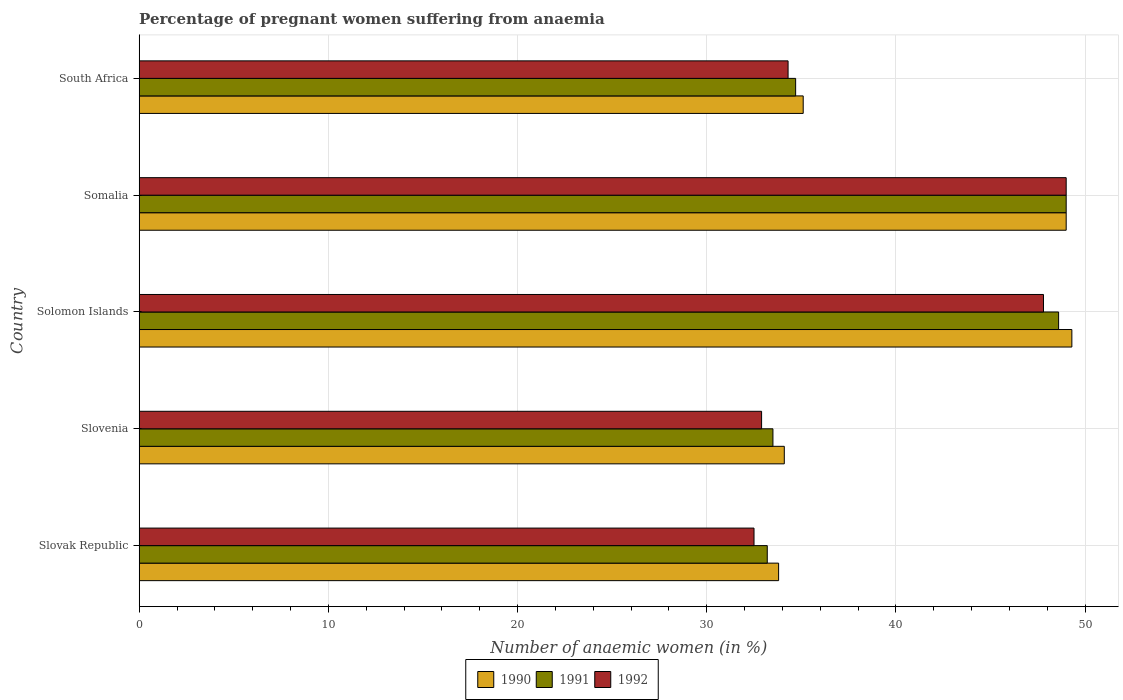How many different coloured bars are there?
Keep it short and to the point. 3. How many bars are there on the 3rd tick from the bottom?
Keep it short and to the point. 3. What is the label of the 2nd group of bars from the top?
Provide a short and direct response. Somalia. In how many cases, is the number of bars for a given country not equal to the number of legend labels?
Give a very brief answer. 0. What is the number of anaemic women in 1991 in Somalia?
Offer a terse response. 49. Across all countries, what is the minimum number of anaemic women in 1990?
Provide a short and direct response. 33.8. In which country was the number of anaemic women in 1990 maximum?
Your response must be concise. Solomon Islands. In which country was the number of anaemic women in 1991 minimum?
Give a very brief answer. Slovak Republic. What is the total number of anaemic women in 1992 in the graph?
Your answer should be compact. 196.5. What is the difference between the number of anaemic women in 1991 in Solomon Islands and the number of anaemic women in 1990 in Somalia?
Your response must be concise. -0.4. What is the average number of anaemic women in 1991 per country?
Your answer should be compact. 39.8. What is the difference between the number of anaemic women in 1992 and number of anaemic women in 1991 in Solomon Islands?
Provide a short and direct response. -0.8. What is the ratio of the number of anaemic women in 1990 in Slovak Republic to that in South Africa?
Offer a very short reply. 0.96. Is the number of anaemic women in 1991 in Slovak Republic less than that in Slovenia?
Provide a short and direct response. Yes. Is the difference between the number of anaemic women in 1992 in Slovak Republic and Solomon Islands greater than the difference between the number of anaemic women in 1991 in Slovak Republic and Solomon Islands?
Provide a short and direct response. Yes. What is the difference between the highest and the second highest number of anaemic women in 1990?
Your answer should be very brief. 0.3. What does the 1st bar from the bottom in South Africa represents?
Offer a terse response. 1990. How many countries are there in the graph?
Offer a very short reply. 5. What is the difference between two consecutive major ticks on the X-axis?
Your response must be concise. 10. Are the values on the major ticks of X-axis written in scientific E-notation?
Give a very brief answer. No. Does the graph contain grids?
Make the answer very short. Yes. How many legend labels are there?
Keep it short and to the point. 3. How are the legend labels stacked?
Ensure brevity in your answer.  Horizontal. What is the title of the graph?
Ensure brevity in your answer.  Percentage of pregnant women suffering from anaemia. Does "1972" appear as one of the legend labels in the graph?
Offer a terse response. No. What is the label or title of the X-axis?
Offer a very short reply. Number of anaemic women (in %). What is the Number of anaemic women (in %) of 1990 in Slovak Republic?
Your answer should be very brief. 33.8. What is the Number of anaemic women (in %) of 1991 in Slovak Republic?
Provide a succinct answer. 33.2. What is the Number of anaemic women (in %) of 1992 in Slovak Republic?
Make the answer very short. 32.5. What is the Number of anaemic women (in %) of 1990 in Slovenia?
Provide a short and direct response. 34.1. What is the Number of anaemic women (in %) in 1991 in Slovenia?
Your answer should be compact. 33.5. What is the Number of anaemic women (in %) in 1992 in Slovenia?
Ensure brevity in your answer.  32.9. What is the Number of anaemic women (in %) in 1990 in Solomon Islands?
Your answer should be very brief. 49.3. What is the Number of anaemic women (in %) in 1991 in Solomon Islands?
Your answer should be very brief. 48.6. What is the Number of anaemic women (in %) of 1992 in Solomon Islands?
Your answer should be very brief. 47.8. What is the Number of anaemic women (in %) in 1991 in Somalia?
Offer a terse response. 49. What is the Number of anaemic women (in %) in 1992 in Somalia?
Ensure brevity in your answer.  49. What is the Number of anaemic women (in %) in 1990 in South Africa?
Provide a short and direct response. 35.1. What is the Number of anaemic women (in %) in 1991 in South Africa?
Make the answer very short. 34.7. What is the Number of anaemic women (in %) of 1992 in South Africa?
Give a very brief answer. 34.3. Across all countries, what is the maximum Number of anaemic women (in %) of 1990?
Keep it short and to the point. 49.3. Across all countries, what is the maximum Number of anaemic women (in %) in 1991?
Ensure brevity in your answer.  49. Across all countries, what is the maximum Number of anaemic women (in %) in 1992?
Your answer should be very brief. 49. Across all countries, what is the minimum Number of anaemic women (in %) in 1990?
Your answer should be very brief. 33.8. Across all countries, what is the minimum Number of anaemic women (in %) of 1991?
Make the answer very short. 33.2. Across all countries, what is the minimum Number of anaemic women (in %) of 1992?
Provide a succinct answer. 32.5. What is the total Number of anaemic women (in %) in 1990 in the graph?
Offer a terse response. 201.3. What is the total Number of anaemic women (in %) of 1991 in the graph?
Offer a very short reply. 199. What is the total Number of anaemic women (in %) of 1992 in the graph?
Make the answer very short. 196.5. What is the difference between the Number of anaemic women (in %) of 1991 in Slovak Republic and that in Slovenia?
Offer a terse response. -0.3. What is the difference between the Number of anaemic women (in %) in 1992 in Slovak Republic and that in Slovenia?
Your answer should be very brief. -0.4. What is the difference between the Number of anaemic women (in %) of 1990 in Slovak Republic and that in Solomon Islands?
Keep it short and to the point. -15.5. What is the difference between the Number of anaemic women (in %) of 1991 in Slovak Republic and that in Solomon Islands?
Make the answer very short. -15.4. What is the difference between the Number of anaemic women (in %) in 1992 in Slovak Republic and that in Solomon Islands?
Provide a succinct answer. -15.3. What is the difference between the Number of anaemic women (in %) in 1990 in Slovak Republic and that in Somalia?
Provide a succinct answer. -15.2. What is the difference between the Number of anaemic women (in %) of 1991 in Slovak Republic and that in Somalia?
Offer a terse response. -15.8. What is the difference between the Number of anaemic women (in %) of 1992 in Slovak Republic and that in Somalia?
Make the answer very short. -16.5. What is the difference between the Number of anaemic women (in %) of 1990 in Slovak Republic and that in South Africa?
Offer a terse response. -1.3. What is the difference between the Number of anaemic women (in %) of 1991 in Slovak Republic and that in South Africa?
Ensure brevity in your answer.  -1.5. What is the difference between the Number of anaemic women (in %) in 1992 in Slovak Republic and that in South Africa?
Offer a very short reply. -1.8. What is the difference between the Number of anaemic women (in %) in 1990 in Slovenia and that in Solomon Islands?
Keep it short and to the point. -15.2. What is the difference between the Number of anaemic women (in %) of 1991 in Slovenia and that in Solomon Islands?
Provide a succinct answer. -15.1. What is the difference between the Number of anaemic women (in %) of 1992 in Slovenia and that in Solomon Islands?
Offer a terse response. -14.9. What is the difference between the Number of anaemic women (in %) in 1990 in Slovenia and that in Somalia?
Ensure brevity in your answer.  -14.9. What is the difference between the Number of anaemic women (in %) in 1991 in Slovenia and that in Somalia?
Your answer should be very brief. -15.5. What is the difference between the Number of anaemic women (in %) in 1992 in Slovenia and that in Somalia?
Provide a succinct answer. -16.1. What is the difference between the Number of anaemic women (in %) in 1990 in Slovenia and that in South Africa?
Offer a terse response. -1. What is the difference between the Number of anaemic women (in %) in 1990 in Solomon Islands and that in Somalia?
Your response must be concise. 0.3. What is the difference between the Number of anaemic women (in %) in 1991 in Solomon Islands and that in Somalia?
Your response must be concise. -0.4. What is the difference between the Number of anaemic women (in %) in 1991 in Solomon Islands and that in South Africa?
Keep it short and to the point. 13.9. What is the difference between the Number of anaemic women (in %) in 1992 in Somalia and that in South Africa?
Offer a terse response. 14.7. What is the difference between the Number of anaemic women (in %) of 1990 in Slovak Republic and the Number of anaemic women (in %) of 1992 in Slovenia?
Provide a short and direct response. 0.9. What is the difference between the Number of anaemic women (in %) in 1991 in Slovak Republic and the Number of anaemic women (in %) in 1992 in Slovenia?
Provide a succinct answer. 0.3. What is the difference between the Number of anaemic women (in %) in 1990 in Slovak Republic and the Number of anaemic women (in %) in 1991 in Solomon Islands?
Ensure brevity in your answer.  -14.8. What is the difference between the Number of anaemic women (in %) in 1991 in Slovak Republic and the Number of anaemic women (in %) in 1992 in Solomon Islands?
Give a very brief answer. -14.6. What is the difference between the Number of anaemic women (in %) in 1990 in Slovak Republic and the Number of anaemic women (in %) in 1991 in Somalia?
Offer a terse response. -15.2. What is the difference between the Number of anaemic women (in %) in 1990 in Slovak Republic and the Number of anaemic women (in %) in 1992 in Somalia?
Provide a succinct answer. -15.2. What is the difference between the Number of anaemic women (in %) in 1991 in Slovak Republic and the Number of anaemic women (in %) in 1992 in Somalia?
Your answer should be very brief. -15.8. What is the difference between the Number of anaemic women (in %) in 1990 in Slovak Republic and the Number of anaemic women (in %) in 1991 in South Africa?
Give a very brief answer. -0.9. What is the difference between the Number of anaemic women (in %) in 1990 in Slovenia and the Number of anaemic women (in %) in 1992 in Solomon Islands?
Provide a succinct answer. -13.7. What is the difference between the Number of anaemic women (in %) of 1991 in Slovenia and the Number of anaemic women (in %) of 1992 in Solomon Islands?
Your answer should be very brief. -14.3. What is the difference between the Number of anaemic women (in %) in 1990 in Slovenia and the Number of anaemic women (in %) in 1991 in Somalia?
Provide a short and direct response. -14.9. What is the difference between the Number of anaemic women (in %) in 1990 in Slovenia and the Number of anaemic women (in %) in 1992 in Somalia?
Your answer should be very brief. -14.9. What is the difference between the Number of anaemic women (in %) of 1991 in Slovenia and the Number of anaemic women (in %) of 1992 in Somalia?
Provide a succinct answer. -15.5. What is the difference between the Number of anaemic women (in %) in 1990 in Slovenia and the Number of anaemic women (in %) in 1992 in South Africa?
Keep it short and to the point. -0.2. What is the difference between the Number of anaemic women (in %) of 1991 in Slovenia and the Number of anaemic women (in %) of 1992 in South Africa?
Your answer should be very brief. -0.8. What is the difference between the Number of anaemic women (in %) in 1990 in Solomon Islands and the Number of anaemic women (in %) in 1991 in Somalia?
Give a very brief answer. 0.3. What is the difference between the Number of anaemic women (in %) of 1991 in Solomon Islands and the Number of anaemic women (in %) of 1992 in Somalia?
Offer a very short reply. -0.4. What is the difference between the Number of anaemic women (in %) in 1990 in Solomon Islands and the Number of anaemic women (in %) in 1991 in South Africa?
Keep it short and to the point. 14.6. What is the difference between the Number of anaemic women (in %) of 1990 in Somalia and the Number of anaemic women (in %) of 1991 in South Africa?
Ensure brevity in your answer.  14.3. What is the difference between the Number of anaemic women (in %) of 1990 in Somalia and the Number of anaemic women (in %) of 1992 in South Africa?
Keep it short and to the point. 14.7. What is the average Number of anaemic women (in %) in 1990 per country?
Your answer should be compact. 40.26. What is the average Number of anaemic women (in %) in 1991 per country?
Provide a short and direct response. 39.8. What is the average Number of anaemic women (in %) of 1992 per country?
Give a very brief answer. 39.3. What is the difference between the Number of anaemic women (in %) in 1990 and Number of anaemic women (in %) in 1991 in Slovak Republic?
Your response must be concise. 0.6. What is the difference between the Number of anaemic women (in %) of 1990 and Number of anaemic women (in %) of 1992 in Slovak Republic?
Provide a short and direct response. 1.3. What is the difference between the Number of anaemic women (in %) of 1991 and Number of anaemic women (in %) of 1992 in Slovak Republic?
Give a very brief answer. 0.7. What is the difference between the Number of anaemic women (in %) in 1990 and Number of anaemic women (in %) in 1991 in Slovenia?
Ensure brevity in your answer.  0.6. What is the difference between the Number of anaemic women (in %) in 1990 and Number of anaemic women (in %) in 1992 in Slovenia?
Your answer should be very brief. 1.2. What is the difference between the Number of anaemic women (in %) in 1990 and Number of anaemic women (in %) in 1992 in Solomon Islands?
Your answer should be very brief. 1.5. What is the difference between the Number of anaemic women (in %) in 1991 and Number of anaemic women (in %) in 1992 in Solomon Islands?
Your answer should be compact. 0.8. What is the difference between the Number of anaemic women (in %) in 1990 and Number of anaemic women (in %) in 1991 in South Africa?
Provide a succinct answer. 0.4. What is the difference between the Number of anaemic women (in %) in 1991 and Number of anaemic women (in %) in 1992 in South Africa?
Your response must be concise. 0.4. What is the ratio of the Number of anaemic women (in %) of 1990 in Slovak Republic to that in Slovenia?
Your answer should be very brief. 0.99. What is the ratio of the Number of anaemic women (in %) in 1991 in Slovak Republic to that in Slovenia?
Offer a very short reply. 0.99. What is the ratio of the Number of anaemic women (in %) in 1990 in Slovak Republic to that in Solomon Islands?
Offer a very short reply. 0.69. What is the ratio of the Number of anaemic women (in %) of 1991 in Slovak Republic to that in Solomon Islands?
Make the answer very short. 0.68. What is the ratio of the Number of anaemic women (in %) in 1992 in Slovak Republic to that in Solomon Islands?
Keep it short and to the point. 0.68. What is the ratio of the Number of anaemic women (in %) of 1990 in Slovak Republic to that in Somalia?
Give a very brief answer. 0.69. What is the ratio of the Number of anaemic women (in %) in 1991 in Slovak Republic to that in Somalia?
Keep it short and to the point. 0.68. What is the ratio of the Number of anaemic women (in %) in 1992 in Slovak Republic to that in Somalia?
Your answer should be very brief. 0.66. What is the ratio of the Number of anaemic women (in %) of 1990 in Slovak Republic to that in South Africa?
Provide a succinct answer. 0.96. What is the ratio of the Number of anaemic women (in %) in 1991 in Slovak Republic to that in South Africa?
Give a very brief answer. 0.96. What is the ratio of the Number of anaemic women (in %) of 1992 in Slovak Republic to that in South Africa?
Provide a short and direct response. 0.95. What is the ratio of the Number of anaemic women (in %) in 1990 in Slovenia to that in Solomon Islands?
Keep it short and to the point. 0.69. What is the ratio of the Number of anaemic women (in %) in 1991 in Slovenia to that in Solomon Islands?
Provide a succinct answer. 0.69. What is the ratio of the Number of anaemic women (in %) of 1992 in Slovenia to that in Solomon Islands?
Ensure brevity in your answer.  0.69. What is the ratio of the Number of anaemic women (in %) in 1990 in Slovenia to that in Somalia?
Make the answer very short. 0.7. What is the ratio of the Number of anaemic women (in %) in 1991 in Slovenia to that in Somalia?
Provide a succinct answer. 0.68. What is the ratio of the Number of anaemic women (in %) of 1992 in Slovenia to that in Somalia?
Offer a terse response. 0.67. What is the ratio of the Number of anaemic women (in %) in 1990 in Slovenia to that in South Africa?
Offer a terse response. 0.97. What is the ratio of the Number of anaemic women (in %) in 1991 in Slovenia to that in South Africa?
Offer a terse response. 0.97. What is the ratio of the Number of anaemic women (in %) in 1992 in Slovenia to that in South Africa?
Your answer should be compact. 0.96. What is the ratio of the Number of anaemic women (in %) of 1992 in Solomon Islands to that in Somalia?
Offer a very short reply. 0.98. What is the ratio of the Number of anaemic women (in %) of 1990 in Solomon Islands to that in South Africa?
Your answer should be very brief. 1.4. What is the ratio of the Number of anaemic women (in %) of 1991 in Solomon Islands to that in South Africa?
Provide a succinct answer. 1.4. What is the ratio of the Number of anaemic women (in %) in 1992 in Solomon Islands to that in South Africa?
Offer a terse response. 1.39. What is the ratio of the Number of anaemic women (in %) in 1990 in Somalia to that in South Africa?
Your answer should be compact. 1.4. What is the ratio of the Number of anaemic women (in %) of 1991 in Somalia to that in South Africa?
Your answer should be compact. 1.41. What is the ratio of the Number of anaemic women (in %) in 1992 in Somalia to that in South Africa?
Your answer should be very brief. 1.43. What is the difference between the highest and the second highest Number of anaemic women (in %) in 1990?
Offer a very short reply. 0.3. What is the difference between the highest and the lowest Number of anaemic women (in %) in 1991?
Offer a terse response. 15.8. 